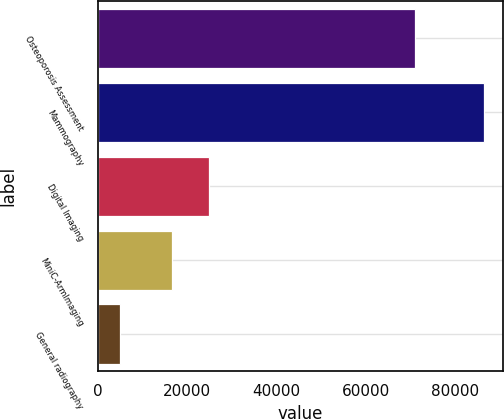Convert chart to OTSL. <chart><loc_0><loc_0><loc_500><loc_500><bar_chart><fcel>Osteoporosis Assessment<fcel>Mammography<fcel>Digital Imaging<fcel>MiniC-ArmImaging<fcel>General radiography<nl><fcel>71081<fcel>86473<fcel>24871.9<fcel>16726<fcel>5014<nl></chart> 